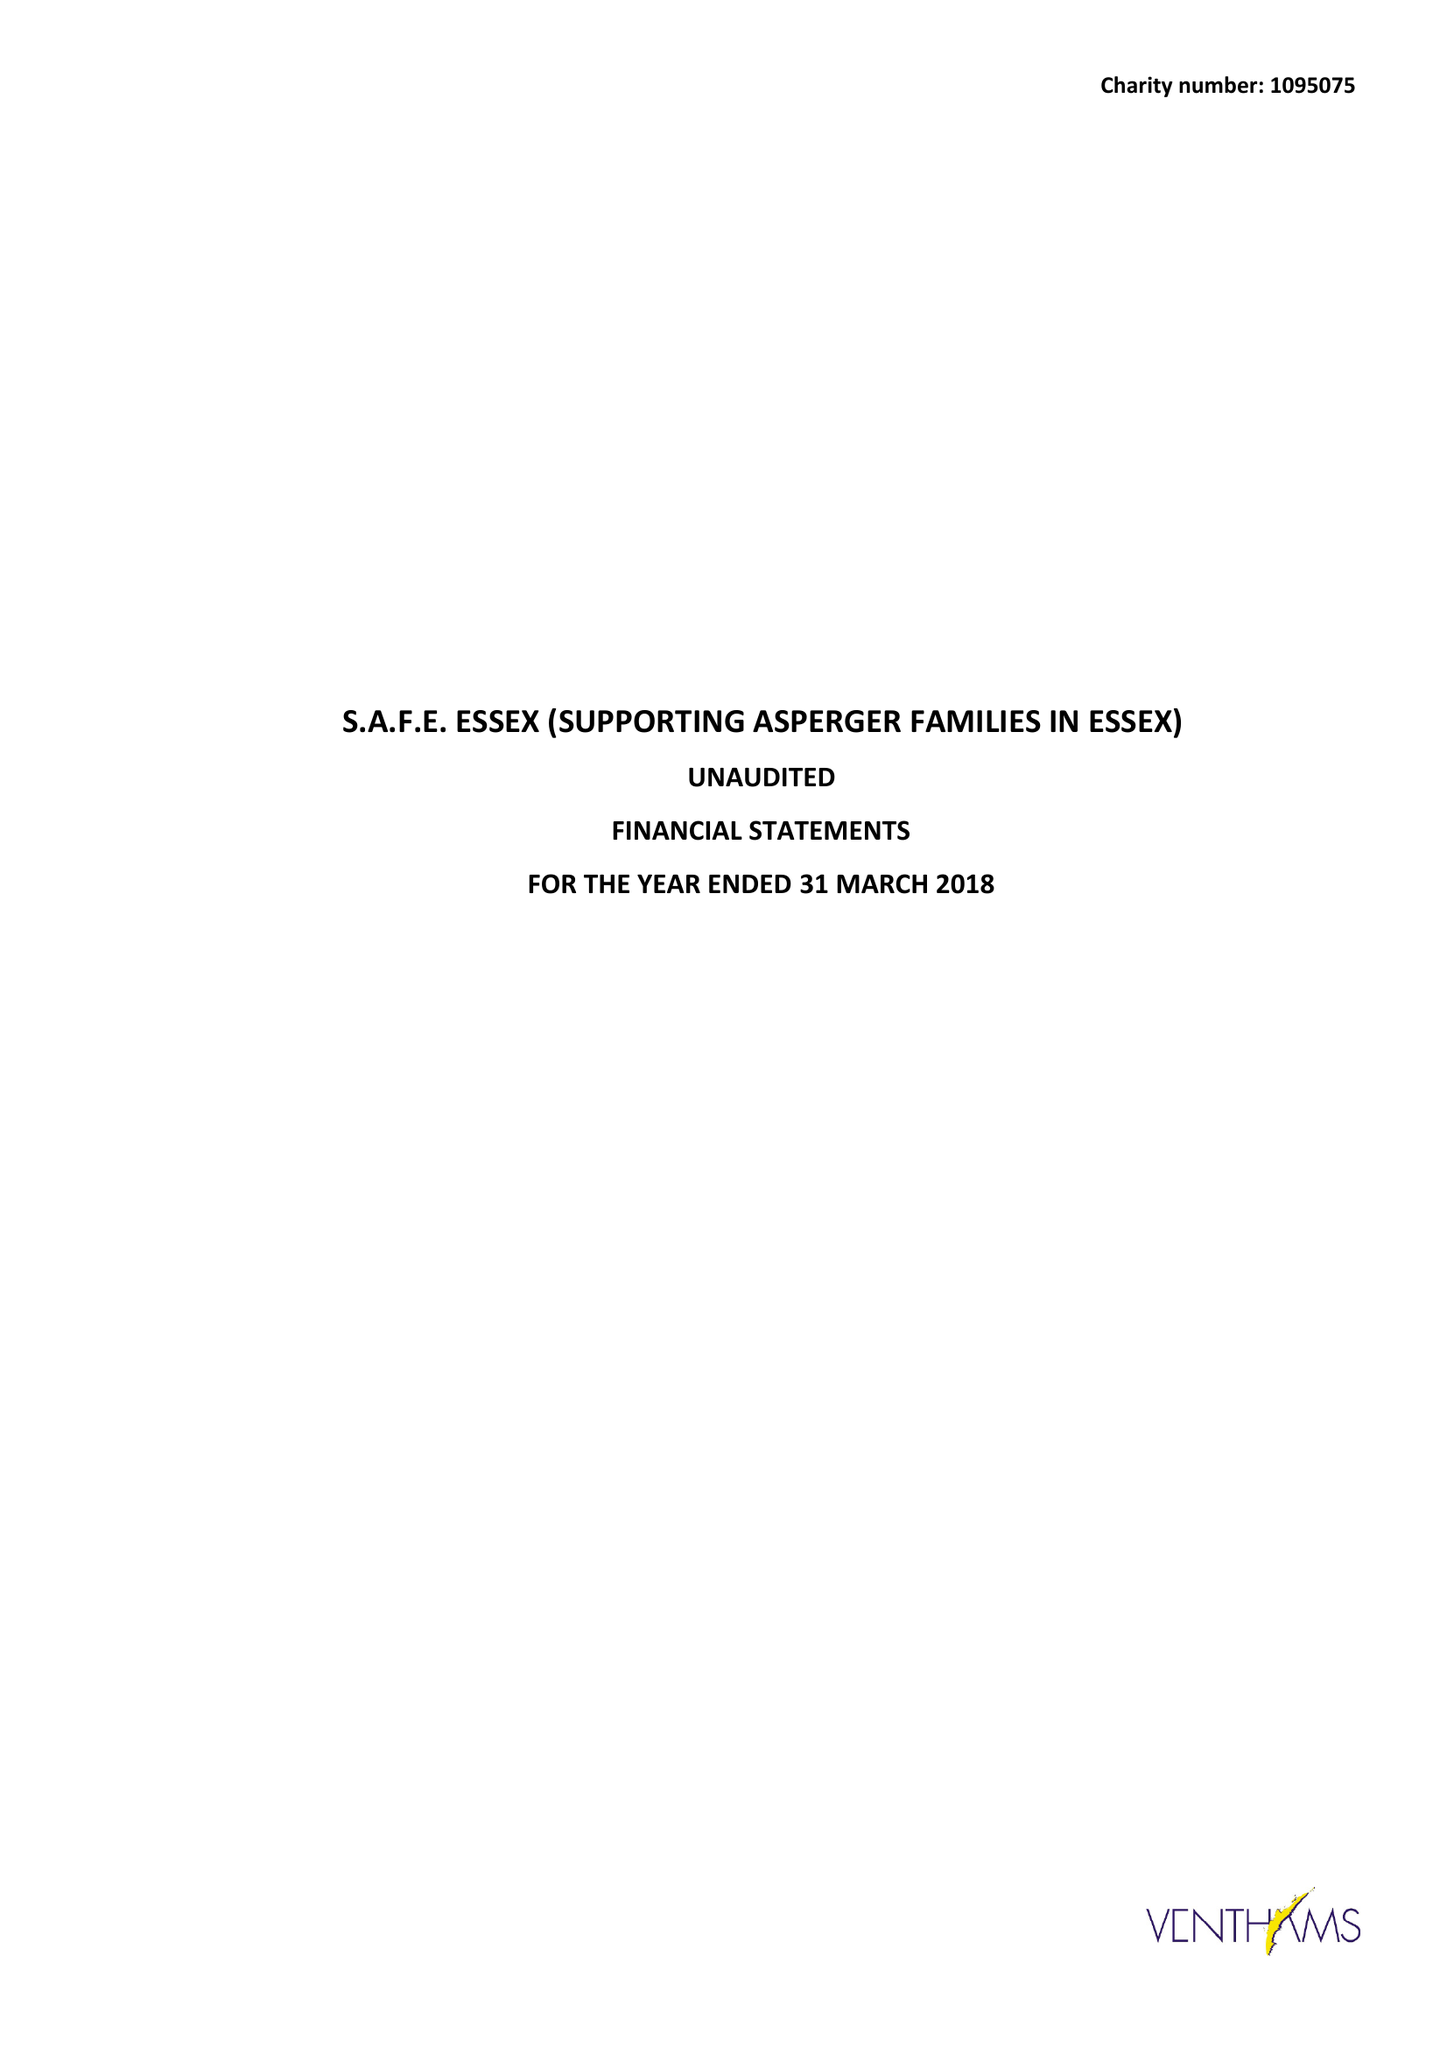What is the value for the income_annually_in_british_pounds?
Answer the question using a single word or phrase. 42256.00 